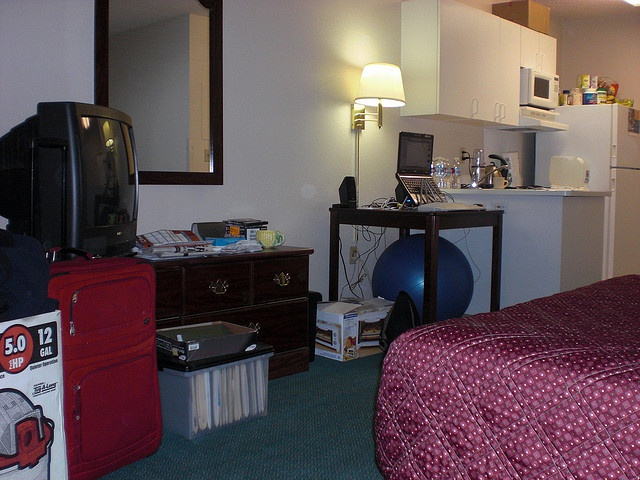Describe the objects in this image and their specific colors. I can see bed in gray, purple, and black tones, suitcase in gray, maroon, black, and purple tones, tv in gray, black, and olive tones, refrigerator in gray, darkgray, and tan tones, and laptop in gray and black tones in this image. 